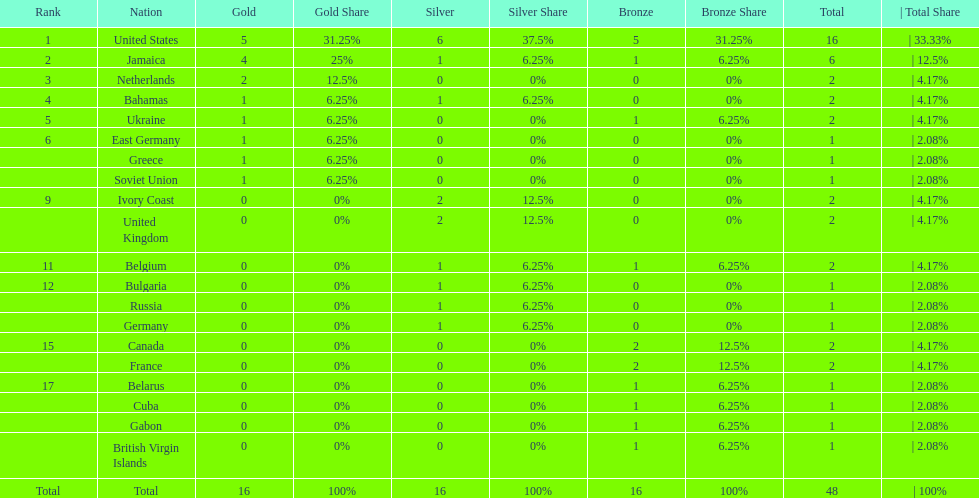What country won more gold medals than any other? United States. 